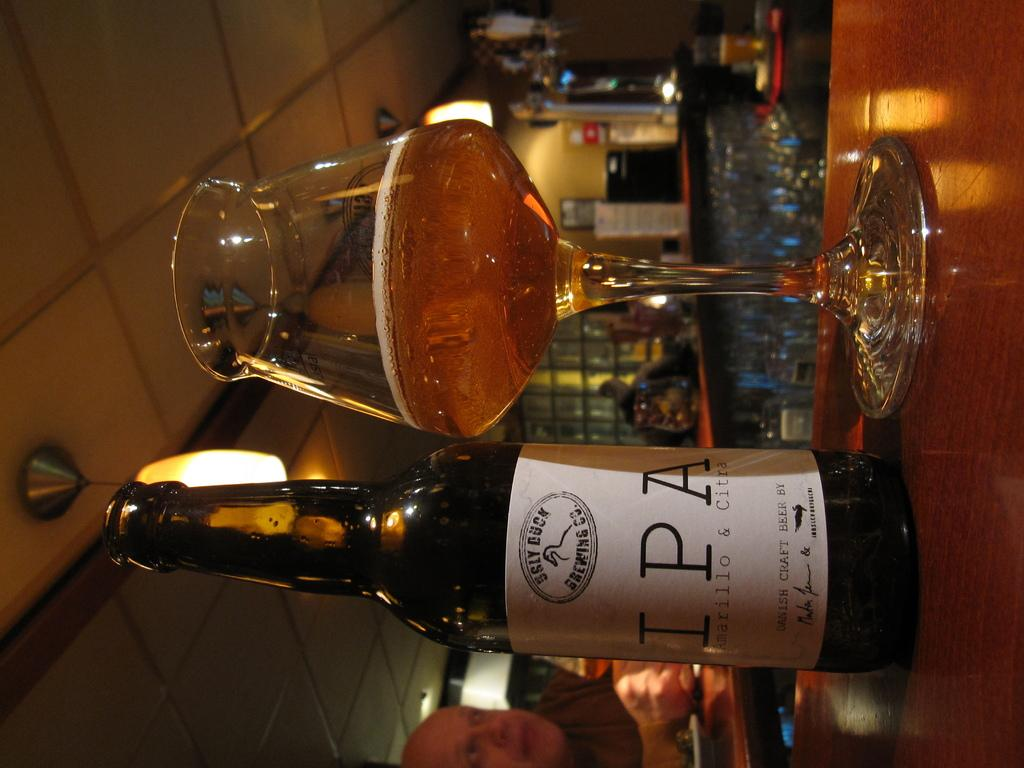<image>
Offer a succinct explanation of the picture presented. A bottle of Sly Duck IPA stands next to a glass with beer in it. 